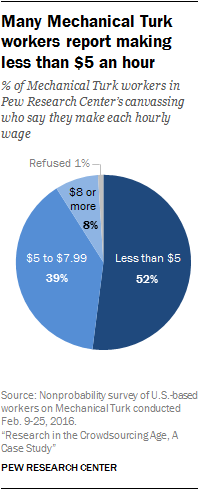Mention a couple of crucial points in this snapshot. The second smallest segment is 8, and its percentage value is unknown. The second smallest segment and the largest segment have a ratio of approximately 0.092361111..., which indicates that the ratio of their lengths is relatively close to 1. 